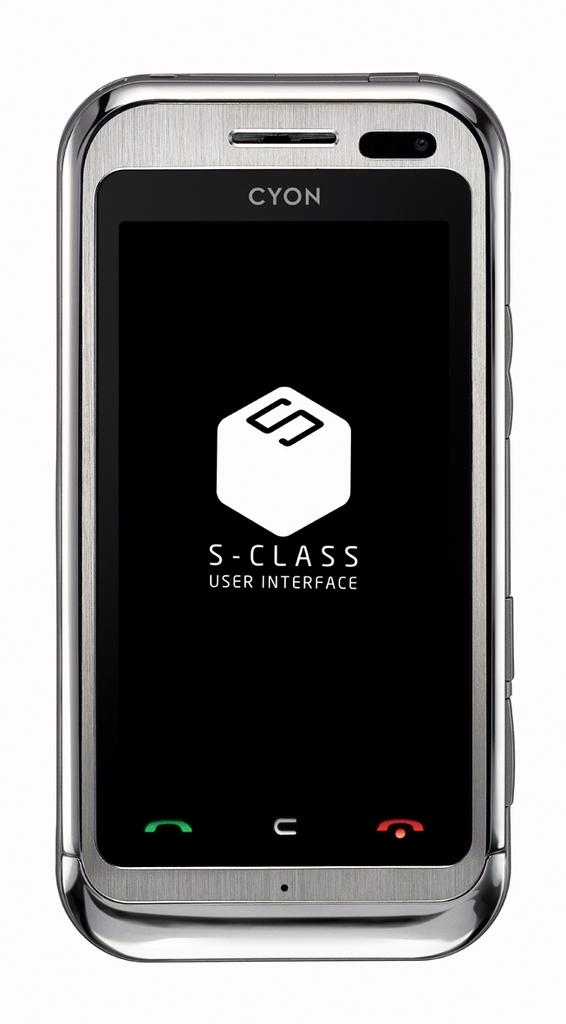What electronic device is present in the picture? There is a mobile phone in the picture. What is displayed on the mobile phone's screen? There is text visible on the mobile phone's screen. What type of jam is being spread on the girl's toast in the image? There is no girl or toast present in the image; it only features a mobile phone. 